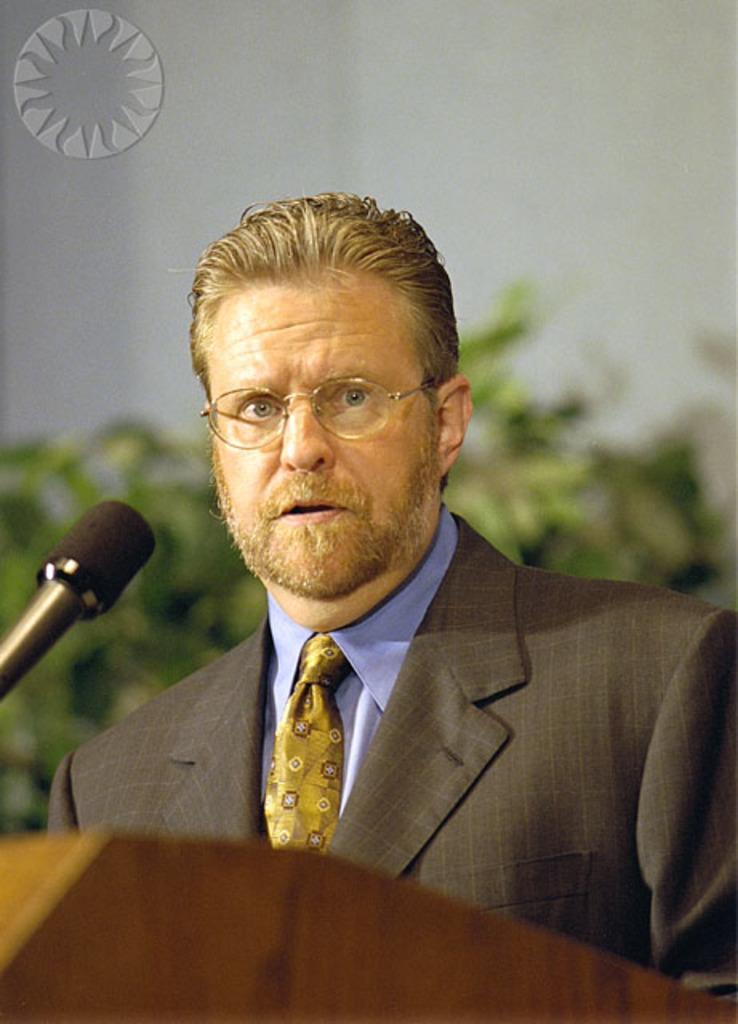Describe this image in one or two sentences. In this picture we can see a person. There is a mic and a podium. Few plants are visible in the background. 